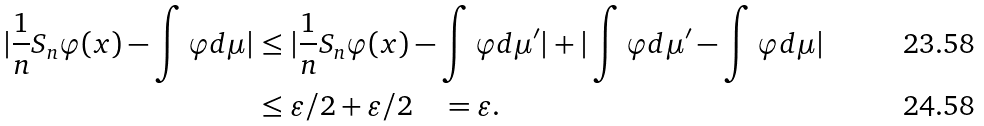Convert formula to latex. <formula><loc_0><loc_0><loc_500><loc_500>| \frac { 1 } { n } S _ { n } \varphi ( x ) - \int \varphi d \mu | & \leq | \frac { 1 } { n } S _ { n } \varphi ( x ) - \int \varphi d \mu ^ { \prime } | + | \int \varphi d \mu ^ { \prime } - \int \varphi d \mu | \\ & \leq \varepsilon / 2 + \varepsilon / 2 \quad = \varepsilon .</formula> 